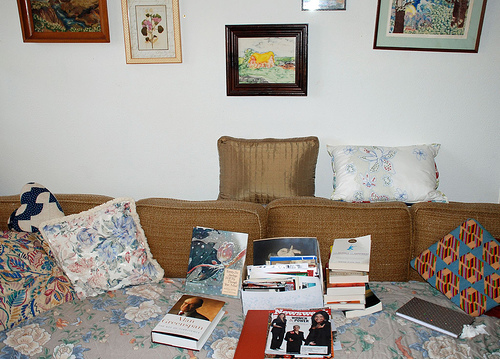<image>
Is there a pillow to the left of the pillow? No. The pillow is not to the left of the pillow. From this viewpoint, they have a different horizontal relationship. Is there a book under the cushion? Yes. The book is positioned underneath the cushion, with the cushion above it in the vertical space. 